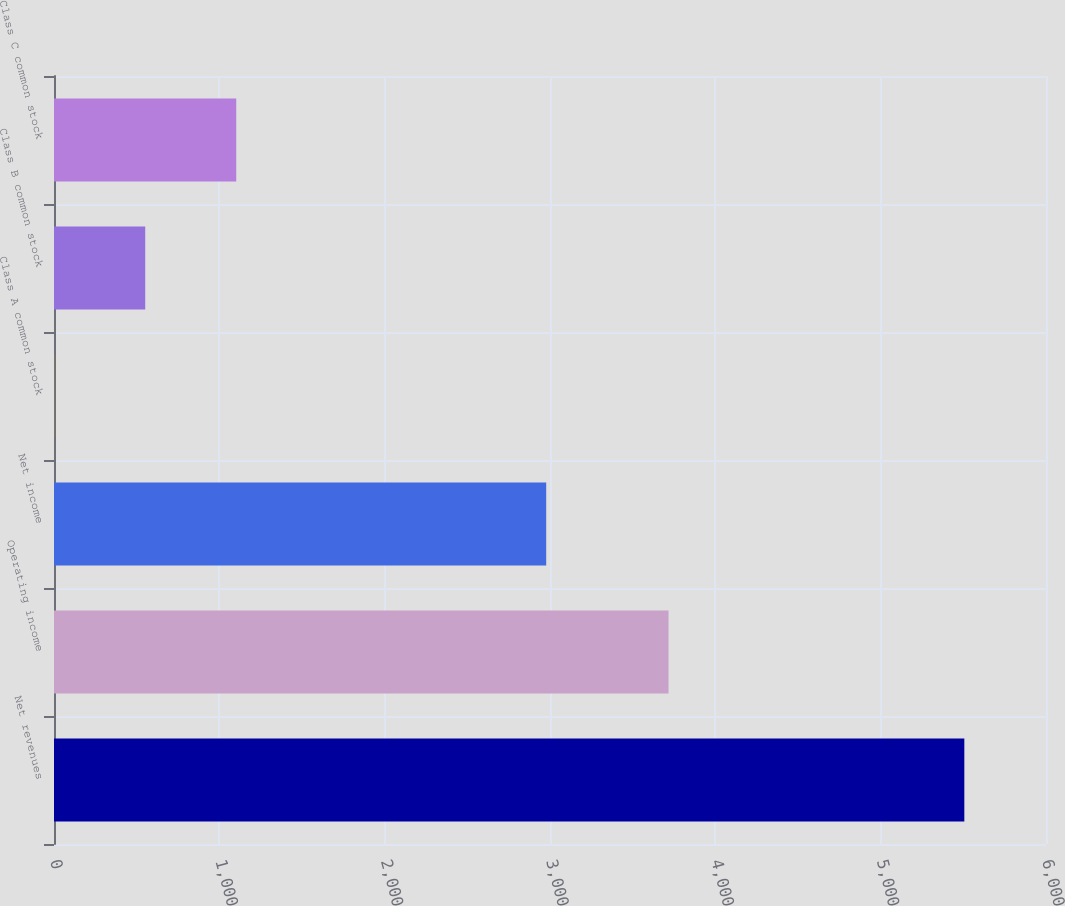Convert chart to OTSL. <chart><loc_0><loc_0><loc_500><loc_500><bar_chart><fcel>Net revenues<fcel>Operating income<fcel>Net income<fcel>Class A common stock<fcel>Class B common stock<fcel>Class C common stock<nl><fcel>5506<fcel>3717<fcel>2977<fcel>1.3<fcel>551.77<fcel>1102.24<nl></chart> 